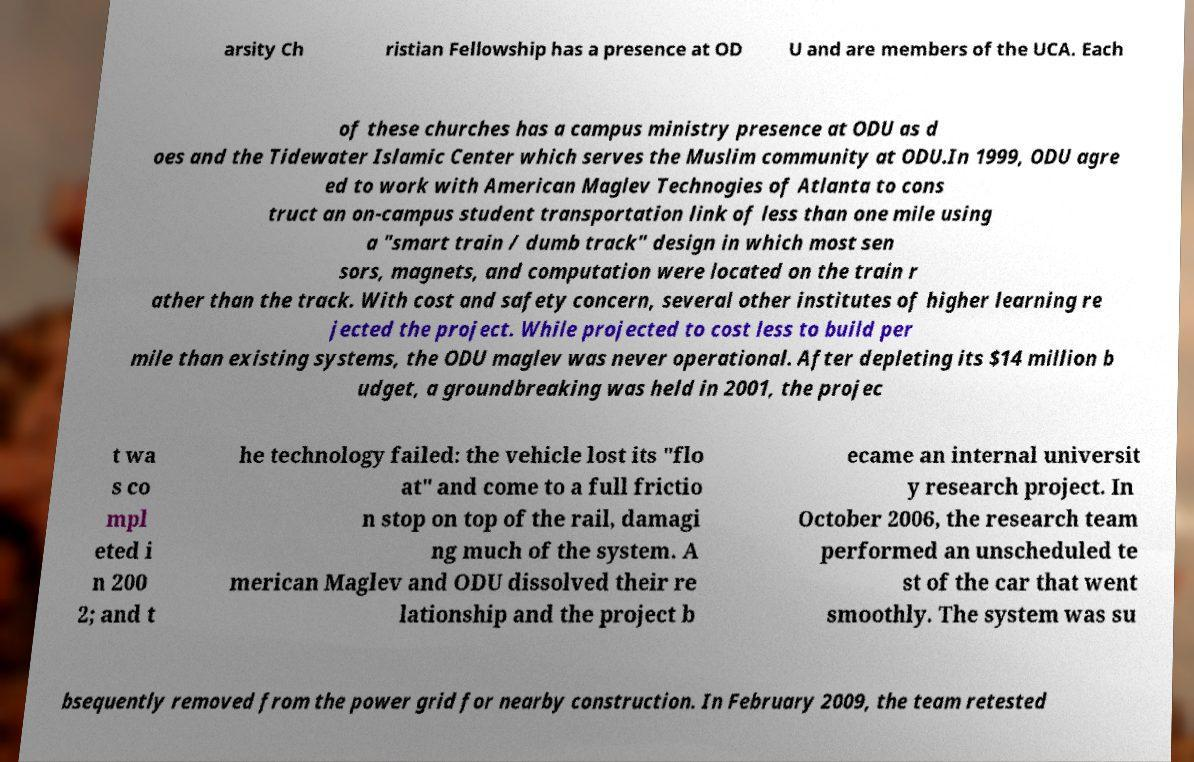Could you assist in decoding the text presented in this image and type it out clearly? arsity Ch ristian Fellowship has a presence at OD U and are members of the UCA. Each of these churches has a campus ministry presence at ODU as d oes and the Tidewater Islamic Center which serves the Muslim community at ODU.In 1999, ODU agre ed to work with American Maglev Technogies of Atlanta to cons truct an on-campus student transportation link of less than one mile using a "smart train / dumb track" design in which most sen sors, magnets, and computation were located on the train r ather than the track. With cost and safety concern, several other institutes of higher learning re jected the project. While projected to cost less to build per mile than existing systems, the ODU maglev was never operational. After depleting its $14 million b udget, a groundbreaking was held in 2001, the projec t wa s co mpl eted i n 200 2; and t he technology failed: the vehicle lost its "flo at" and come to a full frictio n stop on top of the rail, damagi ng much of the system. A merican Maglev and ODU dissolved their re lationship and the project b ecame an internal universit y research project. In October 2006, the research team performed an unscheduled te st of the car that went smoothly. The system was su bsequently removed from the power grid for nearby construction. In February 2009, the team retested 